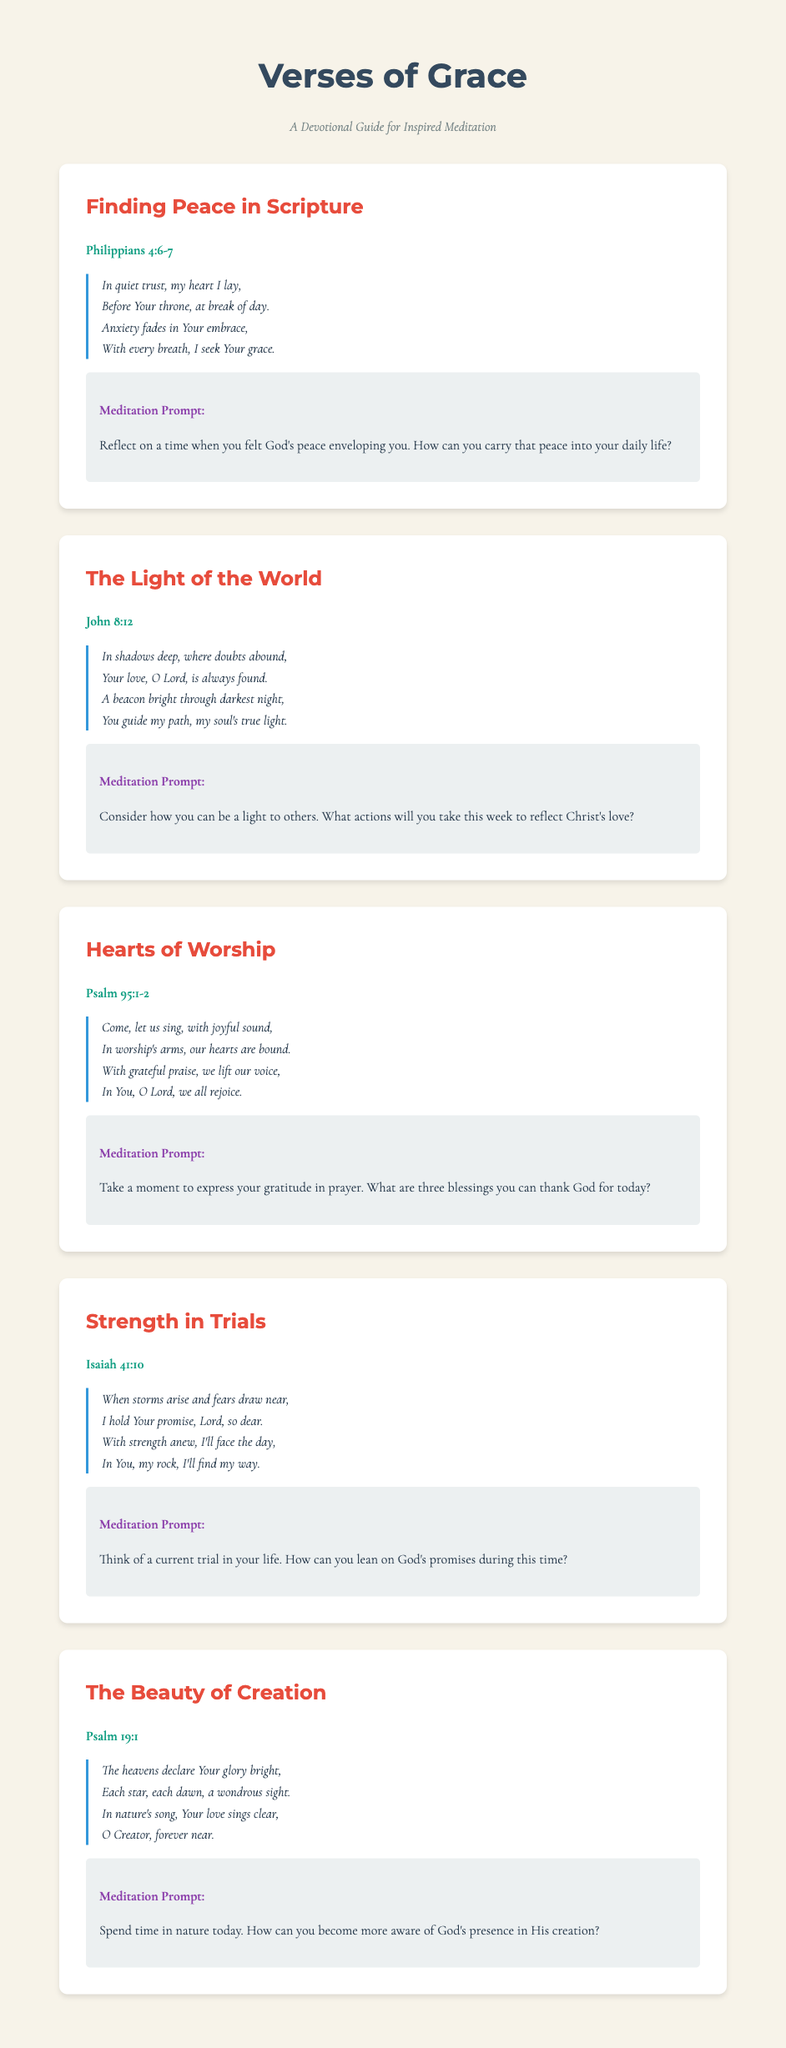What is the title of the devotional guide? The title of the devotional guide is prominently displayed in the header section of the document.
Answer: Verses of Grace How many sections are included in the document? Each section of the document is clearly defined, and the number of these sections can be counted.
Answer: Five Which scripture passage accompanies the theme "Finding Peace in Scripture"? Each section features a scripture passage at the beginning, corresponding to its theme.
Answer: Philippians 4:6-7 What is the poetic style used in the poems? The poems are presented in a specific format that is indicated through the presentation style, such as italics and layout.
Answer: Italic What is the meditation prompt for "Hearts of Worship"? The document provides a specific meditation prompt related to each section, which can be directly quoted to provide the answer.
Answer: Take a moment to express your gratitude in prayer. What are three blessings you can thank God for today? What color is used for the section titles? The color for the section titles can be identified visually within the document's design elements.
Answer: Red Which theme encourages reflection on God's creation? Each theme focuses on different aspects of faith, and this particular theme is named clearly in the document.
Answer: The Beauty of Creation What scripture is associated with the section "Strength in Trials"? The scripture linked to this theme is listed in the document at the beginning of the respective section.
Answer: Isaiah 41:10 How does the poem for "The Light of the World" end? The ending of each poem is used to encapsulate the message and emotional tone.
Answer: You guide my path, my soul's true light 